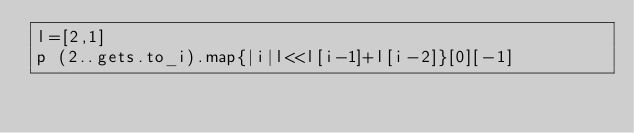Convert code to text. <code><loc_0><loc_0><loc_500><loc_500><_Ruby_>l=[2,1]
p (2..gets.to_i).map{|i|l<<l[i-1]+l[i-2]}[0][-1]</code> 